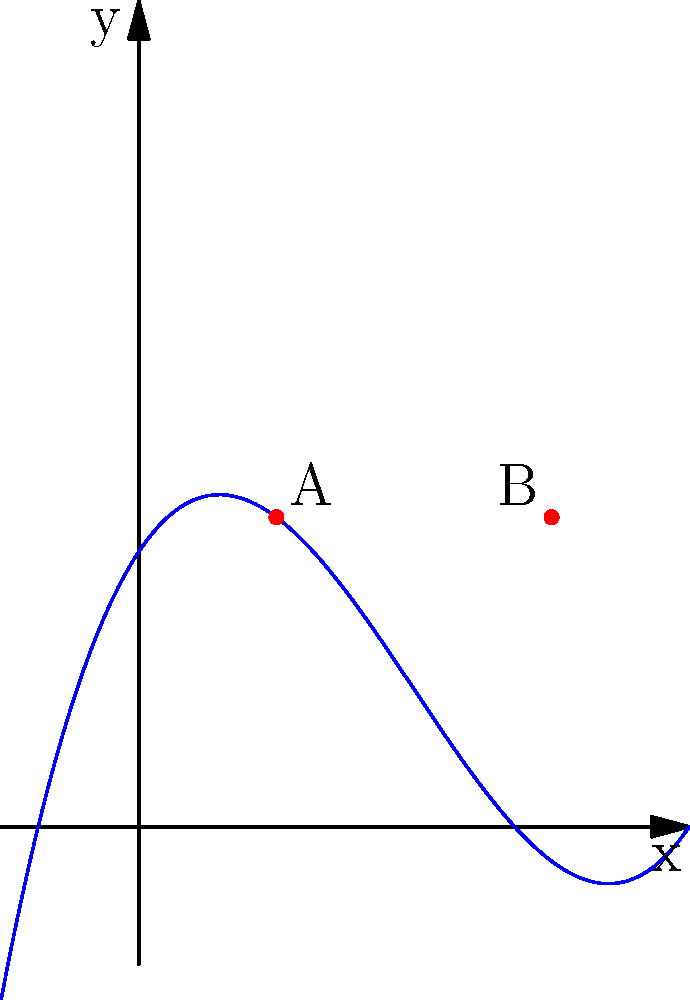As a budding writer, you're exploring mathematical concepts to enhance your storytelling. Consider the polynomial function graphed above. What can you conclude about the behavior of this function near its turning points (labeled A and B) and its end behavior as $x$ approaches positive and negative infinity? Let's analyze this polynomial function step-by-step:

1. Turning points:
   - Point A (1, 2.25) and Point B (3, 2.25) are the turning points of the function.
   - At point A, the function changes from decreasing to increasing (local minimum).
   - At point B, the function changes from increasing to decreasing (local maximum).

2. Behavior near turning points:
   - Near point A: As x approaches 1 from both sides, y values decrease, reach a minimum at x = 1, then increase.
   - Near point B: As x approaches 3 from both sides, y values increase, reach a maximum at x = 3, then decrease.

3. End behavior:
   - As x approaches positive infinity: The y-values increase without bound (the graph goes up).
   - As x approaches negative infinity: The y-values decrease without bound (the graph goes down).

4. Degree of the polynomial:
   - The end behavior suggests this is an odd-degree polynomial (likely cubic) because it has different behaviors at positive and negative infinity.

5. Leading coefficient:
   - The end behavior also indicates a positive leading coefficient, as the function increases for large positive x values.
Answer: The function has local minimum at A, local maximum at B, and increases without bound as x approaches both positive and negative infinity. 